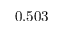<formula> <loc_0><loc_0><loc_500><loc_500>0 . 5 0 3</formula> 